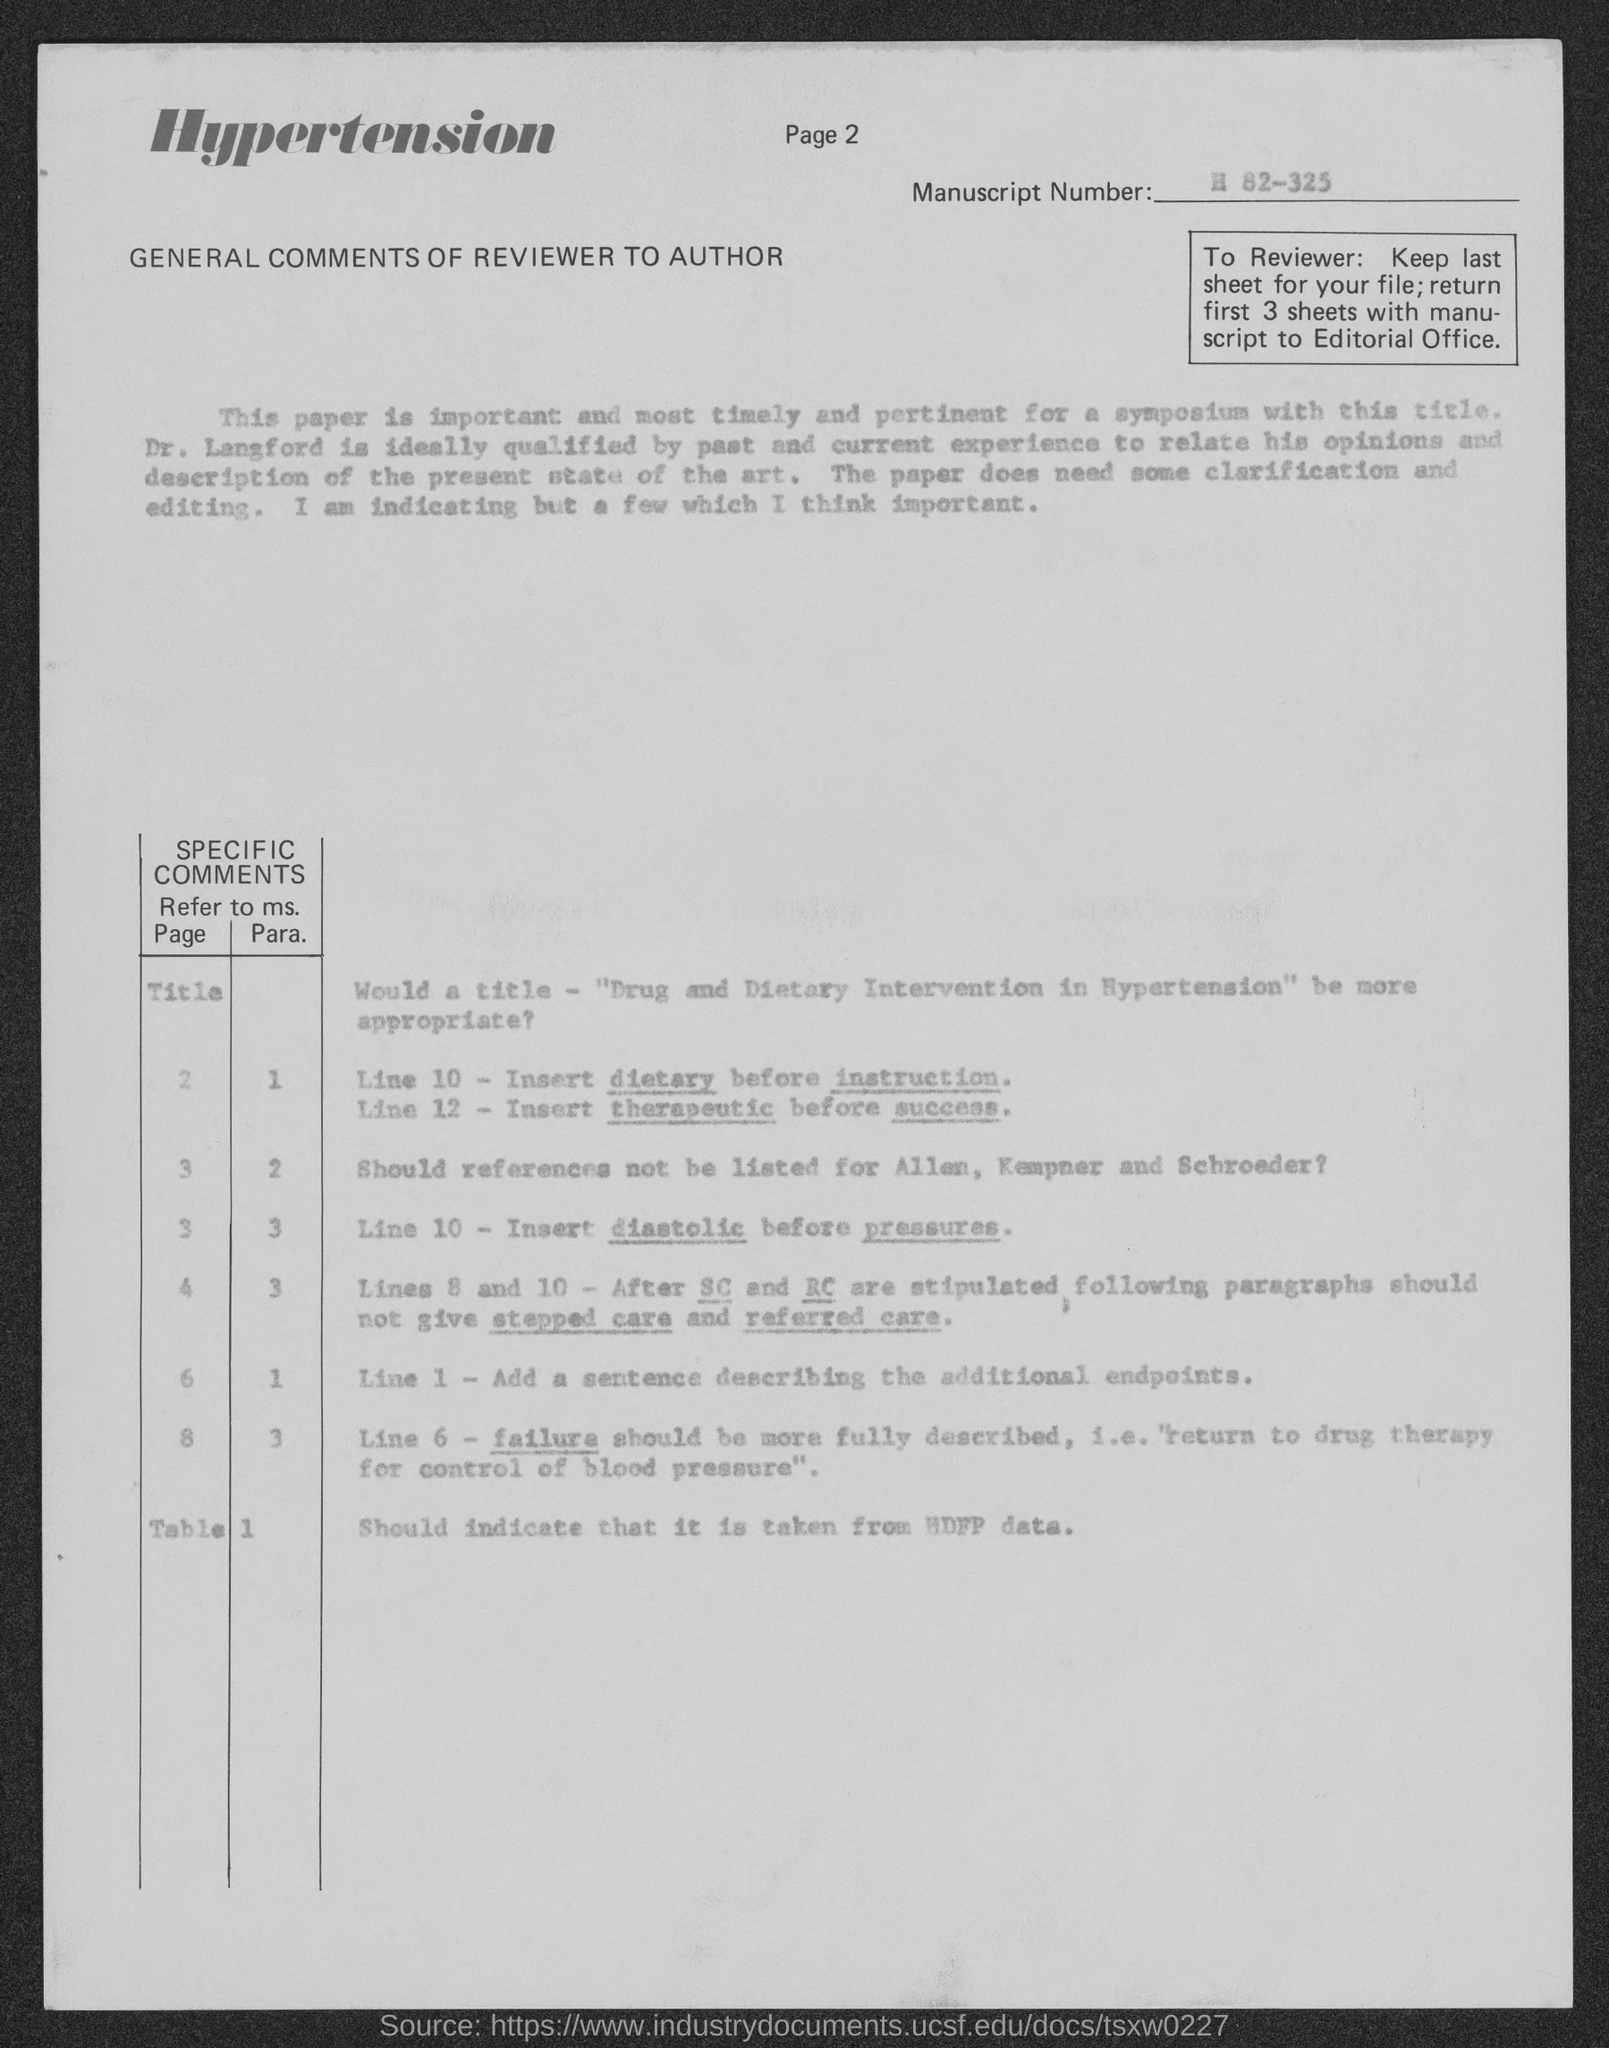What is the page number at top of the page?
Make the answer very short. Page 2. What is the manuscript number ?
Offer a very short reply. H 82-325. 